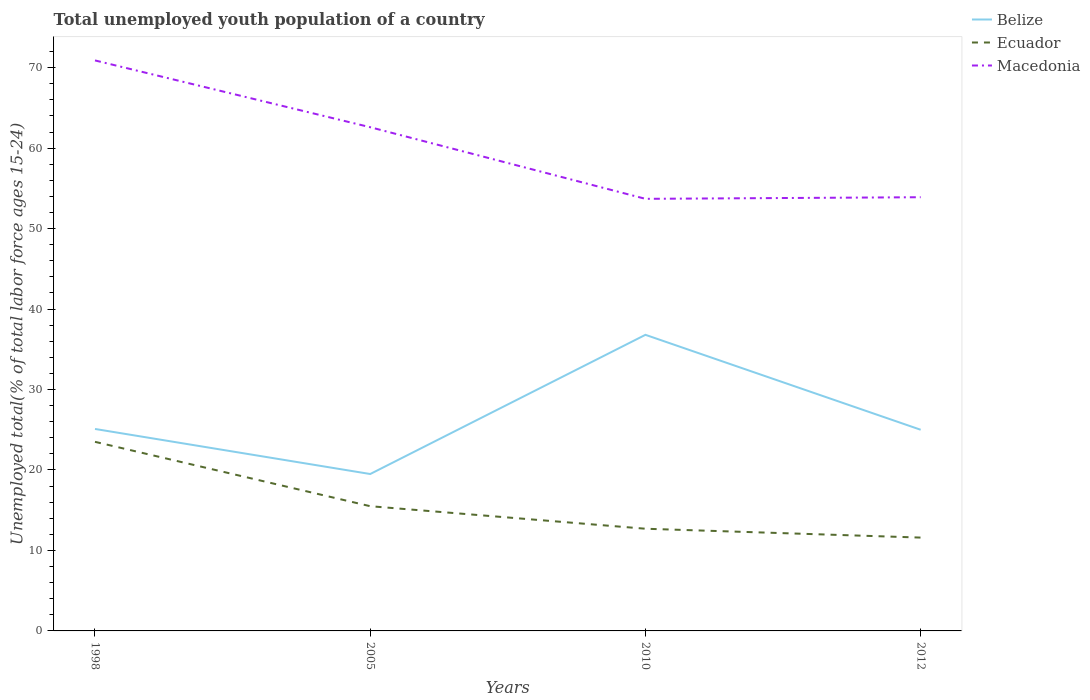Across all years, what is the maximum percentage of total unemployed youth population of a country in Macedonia?
Your answer should be compact. 53.7. In which year was the percentage of total unemployed youth population of a country in Ecuador maximum?
Your answer should be very brief. 2012. What is the total percentage of total unemployed youth population of a country in Ecuador in the graph?
Your answer should be very brief. 1.1. What is the difference between the highest and the second highest percentage of total unemployed youth population of a country in Ecuador?
Offer a very short reply. 11.9. What is the difference between the highest and the lowest percentage of total unemployed youth population of a country in Ecuador?
Make the answer very short. 1. Does the graph contain grids?
Give a very brief answer. No. Where does the legend appear in the graph?
Provide a succinct answer. Top right. How are the legend labels stacked?
Your response must be concise. Vertical. What is the title of the graph?
Make the answer very short. Total unemployed youth population of a country. Does "Samoa" appear as one of the legend labels in the graph?
Your answer should be compact. No. What is the label or title of the Y-axis?
Your answer should be very brief. Unemployed total(% of total labor force ages 15-24). What is the Unemployed total(% of total labor force ages 15-24) of Belize in 1998?
Make the answer very short. 25.1. What is the Unemployed total(% of total labor force ages 15-24) of Macedonia in 1998?
Make the answer very short. 70.9. What is the Unemployed total(% of total labor force ages 15-24) of Belize in 2005?
Your response must be concise. 19.5. What is the Unemployed total(% of total labor force ages 15-24) in Macedonia in 2005?
Provide a short and direct response. 62.6. What is the Unemployed total(% of total labor force ages 15-24) of Belize in 2010?
Make the answer very short. 36.8. What is the Unemployed total(% of total labor force ages 15-24) of Ecuador in 2010?
Ensure brevity in your answer.  12.7. What is the Unemployed total(% of total labor force ages 15-24) of Macedonia in 2010?
Provide a short and direct response. 53.7. What is the Unemployed total(% of total labor force ages 15-24) in Belize in 2012?
Ensure brevity in your answer.  25. What is the Unemployed total(% of total labor force ages 15-24) in Ecuador in 2012?
Your answer should be very brief. 11.6. What is the Unemployed total(% of total labor force ages 15-24) in Macedonia in 2012?
Give a very brief answer. 53.9. Across all years, what is the maximum Unemployed total(% of total labor force ages 15-24) in Belize?
Offer a terse response. 36.8. Across all years, what is the maximum Unemployed total(% of total labor force ages 15-24) of Ecuador?
Make the answer very short. 23.5. Across all years, what is the maximum Unemployed total(% of total labor force ages 15-24) in Macedonia?
Ensure brevity in your answer.  70.9. Across all years, what is the minimum Unemployed total(% of total labor force ages 15-24) of Ecuador?
Your answer should be very brief. 11.6. Across all years, what is the minimum Unemployed total(% of total labor force ages 15-24) of Macedonia?
Provide a short and direct response. 53.7. What is the total Unemployed total(% of total labor force ages 15-24) in Belize in the graph?
Keep it short and to the point. 106.4. What is the total Unemployed total(% of total labor force ages 15-24) of Ecuador in the graph?
Offer a terse response. 63.3. What is the total Unemployed total(% of total labor force ages 15-24) of Macedonia in the graph?
Your answer should be very brief. 241.1. What is the difference between the Unemployed total(% of total labor force ages 15-24) of Belize in 1998 and that in 2005?
Your answer should be compact. 5.6. What is the difference between the Unemployed total(% of total labor force ages 15-24) in Macedonia in 1998 and that in 2005?
Your response must be concise. 8.3. What is the difference between the Unemployed total(% of total labor force ages 15-24) of Ecuador in 1998 and that in 2012?
Offer a very short reply. 11.9. What is the difference between the Unemployed total(% of total labor force ages 15-24) in Belize in 2005 and that in 2010?
Your answer should be very brief. -17.3. What is the difference between the Unemployed total(% of total labor force ages 15-24) in Ecuador in 2005 and that in 2010?
Make the answer very short. 2.8. What is the difference between the Unemployed total(% of total labor force ages 15-24) of Macedonia in 2005 and that in 2010?
Provide a short and direct response. 8.9. What is the difference between the Unemployed total(% of total labor force ages 15-24) of Ecuador in 2010 and that in 2012?
Your answer should be compact. 1.1. What is the difference between the Unemployed total(% of total labor force ages 15-24) in Macedonia in 2010 and that in 2012?
Your answer should be compact. -0.2. What is the difference between the Unemployed total(% of total labor force ages 15-24) in Belize in 1998 and the Unemployed total(% of total labor force ages 15-24) in Macedonia in 2005?
Your answer should be very brief. -37.5. What is the difference between the Unemployed total(% of total labor force ages 15-24) in Ecuador in 1998 and the Unemployed total(% of total labor force ages 15-24) in Macedonia in 2005?
Your response must be concise. -39.1. What is the difference between the Unemployed total(% of total labor force ages 15-24) in Belize in 1998 and the Unemployed total(% of total labor force ages 15-24) in Macedonia in 2010?
Your response must be concise. -28.6. What is the difference between the Unemployed total(% of total labor force ages 15-24) in Ecuador in 1998 and the Unemployed total(% of total labor force ages 15-24) in Macedonia in 2010?
Ensure brevity in your answer.  -30.2. What is the difference between the Unemployed total(% of total labor force ages 15-24) of Belize in 1998 and the Unemployed total(% of total labor force ages 15-24) of Ecuador in 2012?
Offer a very short reply. 13.5. What is the difference between the Unemployed total(% of total labor force ages 15-24) of Belize in 1998 and the Unemployed total(% of total labor force ages 15-24) of Macedonia in 2012?
Keep it short and to the point. -28.8. What is the difference between the Unemployed total(% of total labor force ages 15-24) in Ecuador in 1998 and the Unemployed total(% of total labor force ages 15-24) in Macedonia in 2012?
Offer a terse response. -30.4. What is the difference between the Unemployed total(% of total labor force ages 15-24) in Belize in 2005 and the Unemployed total(% of total labor force ages 15-24) in Ecuador in 2010?
Provide a succinct answer. 6.8. What is the difference between the Unemployed total(% of total labor force ages 15-24) in Belize in 2005 and the Unemployed total(% of total labor force ages 15-24) in Macedonia in 2010?
Provide a short and direct response. -34.2. What is the difference between the Unemployed total(% of total labor force ages 15-24) of Ecuador in 2005 and the Unemployed total(% of total labor force ages 15-24) of Macedonia in 2010?
Ensure brevity in your answer.  -38.2. What is the difference between the Unemployed total(% of total labor force ages 15-24) in Belize in 2005 and the Unemployed total(% of total labor force ages 15-24) in Ecuador in 2012?
Give a very brief answer. 7.9. What is the difference between the Unemployed total(% of total labor force ages 15-24) in Belize in 2005 and the Unemployed total(% of total labor force ages 15-24) in Macedonia in 2012?
Provide a short and direct response. -34.4. What is the difference between the Unemployed total(% of total labor force ages 15-24) of Ecuador in 2005 and the Unemployed total(% of total labor force ages 15-24) of Macedonia in 2012?
Provide a short and direct response. -38.4. What is the difference between the Unemployed total(% of total labor force ages 15-24) in Belize in 2010 and the Unemployed total(% of total labor force ages 15-24) in Ecuador in 2012?
Give a very brief answer. 25.2. What is the difference between the Unemployed total(% of total labor force ages 15-24) of Belize in 2010 and the Unemployed total(% of total labor force ages 15-24) of Macedonia in 2012?
Ensure brevity in your answer.  -17.1. What is the difference between the Unemployed total(% of total labor force ages 15-24) of Ecuador in 2010 and the Unemployed total(% of total labor force ages 15-24) of Macedonia in 2012?
Offer a very short reply. -41.2. What is the average Unemployed total(% of total labor force ages 15-24) of Belize per year?
Give a very brief answer. 26.6. What is the average Unemployed total(% of total labor force ages 15-24) in Ecuador per year?
Offer a very short reply. 15.82. What is the average Unemployed total(% of total labor force ages 15-24) of Macedonia per year?
Provide a succinct answer. 60.27. In the year 1998, what is the difference between the Unemployed total(% of total labor force ages 15-24) of Belize and Unemployed total(% of total labor force ages 15-24) of Macedonia?
Offer a very short reply. -45.8. In the year 1998, what is the difference between the Unemployed total(% of total labor force ages 15-24) in Ecuador and Unemployed total(% of total labor force ages 15-24) in Macedonia?
Your response must be concise. -47.4. In the year 2005, what is the difference between the Unemployed total(% of total labor force ages 15-24) in Belize and Unemployed total(% of total labor force ages 15-24) in Macedonia?
Your answer should be very brief. -43.1. In the year 2005, what is the difference between the Unemployed total(% of total labor force ages 15-24) in Ecuador and Unemployed total(% of total labor force ages 15-24) in Macedonia?
Ensure brevity in your answer.  -47.1. In the year 2010, what is the difference between the Unemployed total(% of total labor force ages 15-24) in Belize and Unemployed total(% of total labor force ages 15-24) in Ecuador?
Keep it short and to the point. 24.1. In the year 2010, what is the difference between the Unemployed total(% of total labor force ages 15-24) of Belize and Unemployed total(% of total labor force ages 15-24) of Macedonia?
Offer a very short reply. -16.9. In the year 2010, what is the difference between the Unemployed total(% of total labor force ages 15-24) in Ecuador and Unemployed total(% of total labor force ages 15-24) in Macedonia?
Make the answer very short. -41. In the year 2012, what is the difference between the Unemployed total(% of total labor force ages 15-24) of Belize and Unemployed total(% of total labor force ages 15-24) of Ecuador?
Keep it short and to the point. 13.4. In the year 2012, what is the difference between the Unemployed total(% of total labor force ages 15-24) of Belize and Unemployed total(% of total labor force ages 15-24) of Macedonia?
Provide a short and direct response. -28.9. In the year 2012, what is the difference between the Unemployed total(% of total labor force ages 15-24) in Ecuador and Unemployed total(% of total labor force ages 15-24) in Macedonia?
Your answer should be compact. -42.3. What is the ratio of the Unemployed total(% of total labor force ages 15-24) in Belize in 1998 to that in 2005?
Your answer should be compact. 1.29. What is the ratio of the Unemployed total(% of total labor force ages 15-24) of Ecuador in 1998 to that in 2005?
Ensure brevity in your answer.  1.52. What is the ratio of the Unemployed total(% of total labor force ages 15-24) in Macedonia in 1998 to that in 2005?
Your response must be concise. 1.13. What is the ratio of the Unemployed total(% of total labor force ages 15-24) of Belize in 1998 to that in 2010?
Your answer should be very brief. 0.68. What is the ratio of the Unemployed total(% of total labor force ages 15-24) in Ecuador in 1998 to that in 2010?
Give a very brief answer. 1.85. What is the ratio of the Unemployed total(% of total labor force ages 15-24) in Macedonia in 1998 to that in 2010?
Offer a very short reply. 1.32. What is the ratio of the Unemployed total(% of total labor force ages 15-24) in Ecuador in 1998 to that in 2012?
Provide a succinct answer. 2.03. What is the ratio of the Unemployed total(% of total labor force ages 15-24) in Macedonia in 1998 to that in 2012?
Make the answer very short. 1.32. What is the ratio of the Unemployed total(% of total labor force ages 15-24) in Belize in 2005 to that in 2010?
Ensure brevity in your answer.  0.53. What is the ratio of the Unemployed total(% of total labor force ages 15-24) in Ecuador in 2005 to that in 2010?
Provide a succinct answer. 1.22. What is the ratio of the Unemployed total(% of total labor force ages 15-24) in Macedonia in 2005 to that in 2010?
Make the answer very short. 1.17. What is the ratio of the Unemployed total(% of total labor force ages 15-24) in Belize in 2005 to that in 2012?
Provide a succinct answer. 0.78. What is the ratio of the Unemployed total(% of total labor force ages 15-24) in Ecuador in 2005 to that in 2012?
Give a very brief answer. 1.34. What is the ratio of the Unemployed total(% of total labor force ages 15-24) of Macedonia in 2005 to that in 2012?
Provide a short and direct response. 1.16. What is the ratio of the Unemployed total(% of total labor force ages 15-24) of Belize in 2010 to that in 2012?
Give a very brief answer. 1.47. What is the ratio of the Unemployed total(% of total labor force ages 15-24) of Ecuador in 2010 to that in 2012?
Make the answer very short. 1.09. What is the ratio of the Unemployed total(% of total labor force ages 15-24) of Macedonia in 2010 to that in 2012?
Your response must be concise. 1. What is the difference between the highest and the second highest Unemployed total(% of total labor force ages 15-24) of Belize?
Offer a terse response. 11.7. What is the difference between the highest and the second highest Unemployed total(% of total labor force ages 15-24) of Macedonia?
Keep it short and to the point. 8.3. What is the difference between the highest and the lowest Unemployed total(% of total labor force ages 15-24) of Macedonia?
Make the answer very short. 17.2. 